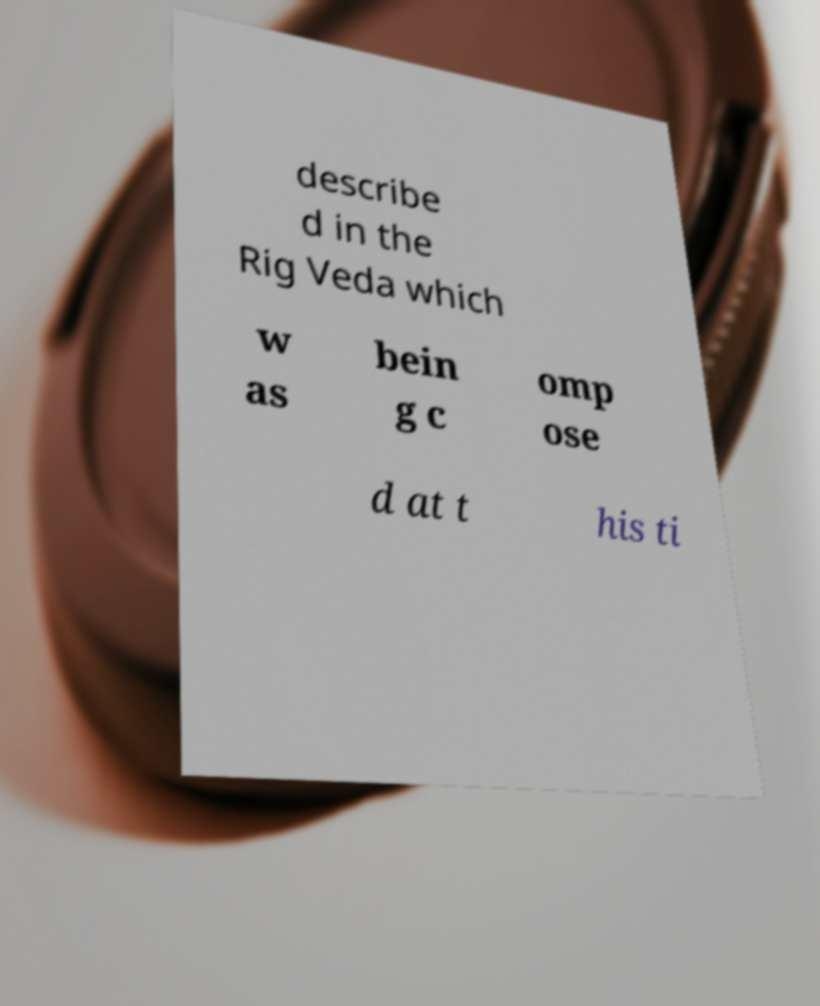Please identify and transcribe the text found in this image. describe d in the Rig Veda which w as bein g c omp ose d at t his ti 